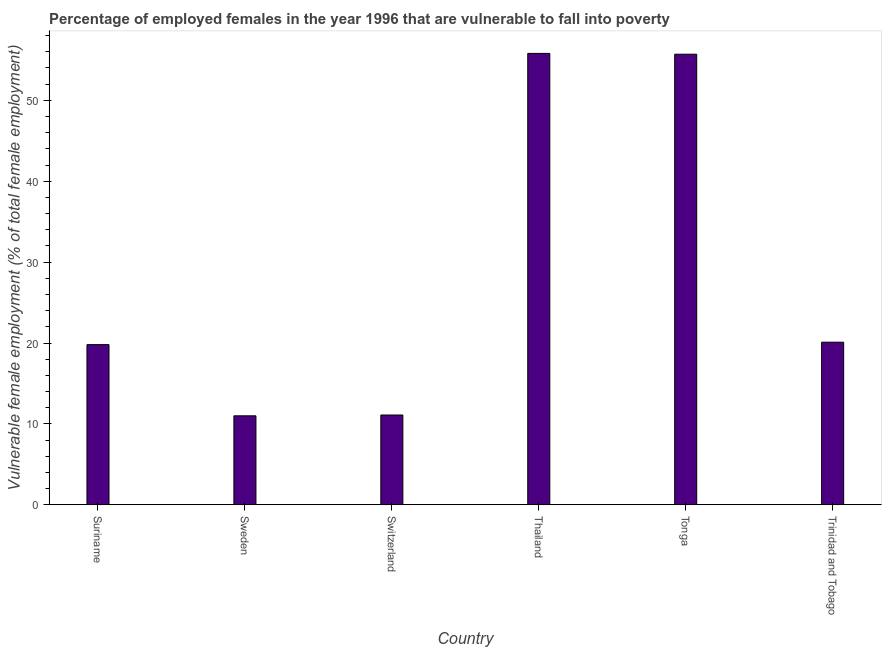Does the graph contain any zero values?
Your response must be concise. No. What is the title of the graph?
Your response must be concise. Percentage of employed females in the year 1996 that are vulnerable to fall into poverty. What is the label or title of the X-axis?
Make the answer very short. Country. What is the label or title of the Y-axis?
Ensure brevity in your answer.  Vulnerable female employment (% of total female employment). What is the percentage of employed females who are vulnerable to fall into poverty in Suriname?
Provide a short and direct response. 19.8. Across all countries, what is the maximum percentage of employed females who are vulnerable to fall into poverty?
Your answer should be compact. 55.8. In which country was the percentage of employed females who are vulnerable to fall into poverty maximum?
Ensure brevity in your answer.  Thailand. In which country was the percentage of employed females who are vulnerable to fall into poverty minimum?
Make the answer very short. Sweden. What is the sum of the percentage of employed females who are vulnerable to fall into poverty?
Your response must be concise. 173.5. What is the difference between the percentage of employed females who are vulnerable to fall into poverty in Tonga and Trinidad and Tobago?
Offer a terse response. 35.6. What is the average percentage of employed females who are vulnerable to fall into poverty per country?
Offer a very short reply. 28.92. What is the median percentage of employed females who are vulnerable to fall into poverty?
Your answer should be very brief. 19.95. In how many countries, is the percentage of employed females who are vulnerable to fall into poverty greater than 18 %?
Your answer should be compact. 4. What is the ratio of the percentage of employed females who are vulnerable to fall into poverty in Sweden to that in Trinidad and Tobago?
Provide a succinct answer. 0.55. Is the percentage of employed females who are vulnerable to fall into poverty in Switzerland less than that in Thailand?
Your answer should be compact. Yes. Is the difference between the percentage of employed females who are vulnerable to fall into poverty in Suriname and Switzerland greater than the difference between any two countries?
Ensure brevity in your answer.  No. What is the difference between the highest and the second highest percentage of employed females who are vulnerable to fall into poverty?
Ensure brevity in your answer.  0.1. What is the difference between the highest and the lowest percentage of employed females who are vulnerable to fall into poverty?
Provide a short and direct response. 44.8. How many bars are there?
Your answer should be compact. 6. Are all the bars in the graph horizontal?
Your answer should be compact. No. What is the difference between two consecutive major ticks on the Y-axis?
Give a very brief answer. 10. Are the values on the major ticks of Y-axis written in scientific E-notation?
Offer a terse response. No. What is the Vulnerable female employment (% of total female employment) of Suriname?
Give a very brief answer. 19.8. What is the Vulnerable female employment (% of total female employment) of Switzerland?
Offer a terse response. 11.1. What is the Vulnerable female employment (% of total female employment) of Thailand?
Keep it short and to the point. 55.8. What is the Vulnerable female employment (% of total female employment) of Tonga?
Ensure brevity in your answer.  55.7. What is the Vulnerable female employment (% of total female employment) in Trinidad and Tobago?
Your answer should be very brief. 20.1. What is the difference between the Vulnerable female employment (% of total female employment) in Suriname and Sweden?
Give a very brief answer. 8.8. What is the difference between the Vulnerable female employment (% of total female employment) in Suriname and Thailand?
Your response must be concise. -36. What is the difference between the Vulnerable female employment (% of total female employment) in Suriname and Tonga?
Your response must be concise. -35.9. What is the difference between the Vulnerable female employment (% of total female employment) in Suriname and Trinidad and Tobago?
Keep it short and to the point. -0.3. What is the difference between the Vulnerable female employment (% of total female employment) in Sweden and Thailand?
Your answer should be compact. -44.8. What is the difference between the Vulnerable female employment (% of total female employment) in Sweden and Tonga?
Provide a short and direct response. -44.7. What is the difference between the Vulnerable female employment (% of total female employment) in Switzerland and Thailand?
Your answer should be very brief. -44.7. What is the difference between the Vulnerable female employment (% of total female employment) in Switzerland and Tonga?
Your response must be concise. -44.6. What is the difference between the Vulnerable female employment (% of total female employment) in Thailand and Tonga?
Offer a terse response. 0.1. What is the difference between the Vulnerable female employment (% of total female employment) in Thailand and Trinidad and Tobago?
Your answer should be very brief. 35.7. What is the difference between the Vulnerable female employment (% of total female employment) in Tonga and Trinidad and Tobago?
Provide a succinct answer. 35.6. What is the ratio of the Vulnerable female employment (% of total female employment) in Suriname to that in Sweden?
Offer a terse response. 1.8. What is the ratio of the Vulnerable female employment (% of total female employment) in Suriname to that in Switzerland?
Give a very brief answer. 1.78. What is the ratio of the Vulnerable female employment (% of total female employment) in Suriname to that in Thailand?
Keep it short and to the point. 0.35. What is the ratio of the Vulnerable female employment (% of total female employment) in Suriname to that in Tonga?
Your answer should be compact. 0.35. What is the ratio of the Vulnerable female employment (% of total female employment) in Sweden to that in Switzerland?
Offer a terse response. 0.99. What is the ratio of the Vulnerable female employment (% of total female employment) in Sweden to that in Thailand?
Offer a terse response. 0.2. What is the ratio of the Vulnerable female employment (% of total female employment) in Sweden to that in Tonga?
Provide a short and direct response. 0.2. What is the ratio of the Vulnerable female employment (% of total female employment) in Sweden to that in Trinidad and Tobago?
Ensure brevity in your answer.  0.55. What is the ratio of the Vulnerable female employment (% of total female employment) in Switzerland to that in Thailand?
Provide a short and direct response. 0.2. What is the ratio of the Vulnerable female employment (% of total female employment) in Switzerland to that in Tonga?
Offer a terse response. 0.2. What is the ratio of the Vulnerable female employment (% of total female employment) in Switzerland to that in Trinidad and Tobago?
Ensure brevity in your answer.  0.55. What is the ratio of the Vulnerable female employment (% of total female employment) in Thailand to that in Tonga?
Provide a succinct answer. 1. What is the ratio of the Vulnerable female employment (% of total female employment) in Thailand to that in Trinidad and Tobago?
Make the answer very short. 2.78. What is the ratio of the Vulnerable female employment (% of total female employment) in Tonga to that in Trinidad and Tobago?
Your response must be concise. 2.77. 